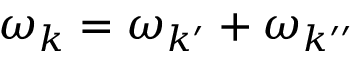<formula> <loc_0><loc_0><loc_500><loc_500>\omega _ { k } = \omega _ { { k } ^ { \prime } } + \omega _ { { k } ^ { \prime \prime } }</formula> 